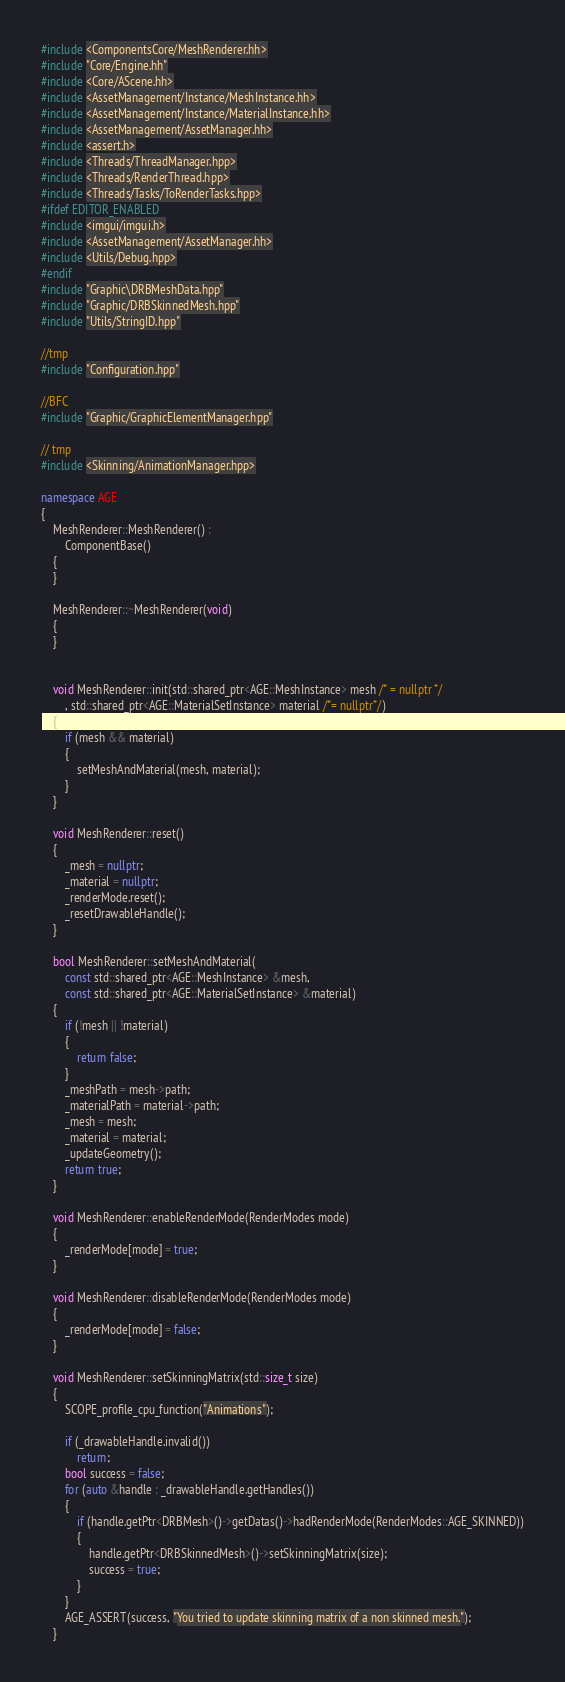Convert code to text. <code><loc_0><loc_0><loc_500><loc_500><_C++_>#include <ComponentsCore/MeshRenderer.hh>
#include "Core/Engine.hh"
#include <Core/AScene.hh>
#include <AssetManagement/Instance/MeshInstance.hh>
#include <AssetManagement/Instance/MaterialInstance.hh>
#include <AssetManagement/AssetManager.hh>
#include <assert.h>
#include <Threads/ThreadManager.hpp>
#include <Threads/RenderThread.hpp>
#include <Threads/Tasks/ToRenderTasks.hpp>
#ifdef EDITOR_ENABLED
#include <imgui/imgui.h>
#include <AssetManagement/AssetManager.hh>
#include <Utils/Debug.hpp>
#endif
#include "Graphic\DRBMeshData.hpp"
#include "Graphic/DRBSkinnedMesh.hpp"
#include "Utils/StringID.hpp"

//tmp
#include "Configuration.hpp"

//BFC
#include "Graphic/GraphicElementManager.hpp"

// tmp
#include <Skinning/AnimationManager.hpp>

namespace AGE
{
	MeshRenderer::MeshRenderer() :
		ComponentBase()
	{
	}

	MeshRenderer::~MeshRenderer(void)
	{
	}


	void MeshRenderer::init(std::shared_ptr<AGE::MeshInstance> mesh /* = nullptr */
		, std::shared_ptr<AGE::MaterialSetInstance> material /*= nullptr*/)
	{
		if (mesh && material)
		{
			setMeshAndMaterial(mesh, material);
		}
	}

	void MeshRenderer::reset()
	{
		_mesh = nullptr;
		_material = nullptr;
		_renderMode.reset();
		_resetDrawableHandle();
	}

	bool MeshRenderer::setMeshAndMaterial(
		const std::shared_ptr<AGE::MeshInstance> &mesh,
		const std::shared_ptr<AGE::MaterialSetInstance> &material)
	{
		if (!mesh || !material)
		{
			return false;
		}
		_meshPath = mesh->path;
		_materialPath = material->path;
		_mesh = mesh;
		_material = material;
		_updateGeometry();
		return true;
	}

	void MeshRenderer::enableRenderMode(RenderModes mode)
	{
		_renderMode[mode] = true;
	}

	void MeshRenderer::disableRenderMode(RenderModes mode)
	{
		_renderMode[mode] = false;
	}

	void MeshRenderer::setSkinningMatrix(std::size_t size)
	{
		SCOPE_profile_cpu_function("Animations");

		if (_drawableHandle.invalid())
			return;
		bool success = false;
		for (auto &handle : _drawableHandle.getHandles())
		{
			if (handle.getPtr<DRBMesh>()->getDatas()->hadRenderMode(RenderModes::AGE_SKINNED))
			{
				handle.getPtr<DRBSkinnedMesh>()->setSkinningMatrix(size);
				success = true;
			}
		}
		AGE_ASSERT(success, "You tried to update skinning matrix of a non skinned mesh.");
	}
</code> 